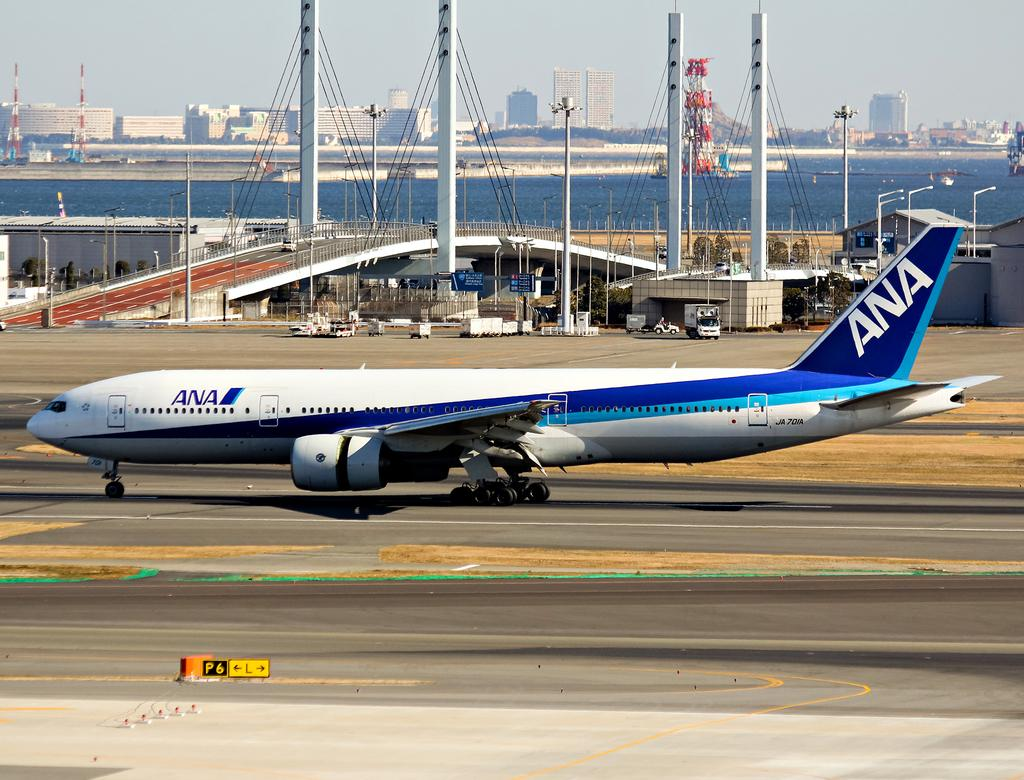<image>
Provide a brief description of the given image. A plane on a runway that is owned by ANA airlines 